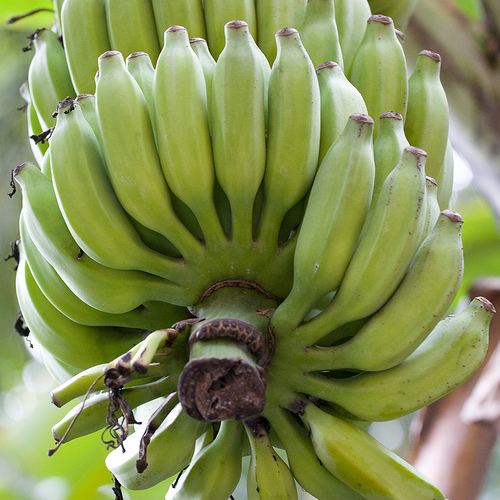<image>
Can you confirm if the banana is next to the leaf? Yes. The banana is positioned adjacent to the leaf, located nearby in the same general area. 